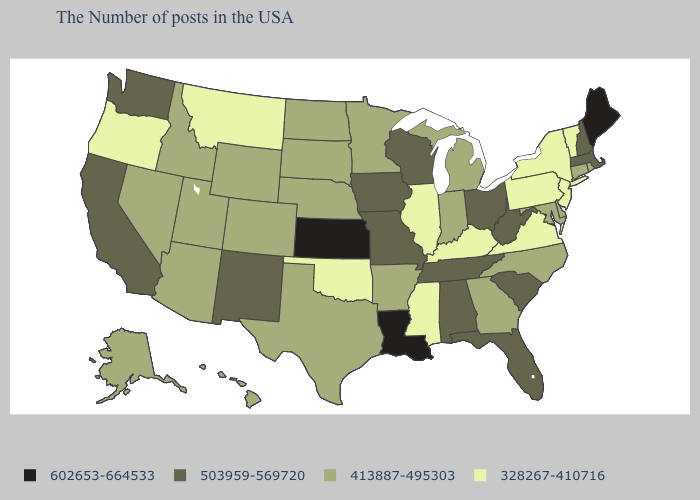Does Indiana have the same value as Kentucky?
Quick response, please. No. What is the lowest value in the USA?
Quick response, please. 328267-410716. How many symbols are there in the legend?
Quick response, please. 4. What is the value of Utah?
Quick response, please. 413887-495303. What is the value of Georgia?
Quick response, please. 413887-495303. Name the states that have a value in the range 413887-495303?
Keep it brief. Rhode Island, Connecticut, Delaware, Maryland, North Carolina, Georgia, Michigan, Indiana, Arkansas, Minnesota, Nebraska, Texas, South Dakota, North Dakota, Wyoming, Colorado, Utah, Arizona, Idaho, Nevada, Alaska, Hawaii. What is the value of Louisiana?
Concise answer only. 602653-664533. Does Rhode Island have a higher value than Maine?
Answer briefly. No. Does the map have missing data?
Answer briefly. No. Name the states that have a value in the range 503959-569720?
Short answer required. Massachusetts, New Hampshire, South Carolina, West Virginia, Ohio, Florida, Alabama, Tennessee, Wisconsin, Missouri, Iowa, New Mexico, California, Washington. What is the lowest value in the MidWest?
Concise answer only. 328267-410716. What is the value of Iowa?
Short answer required. 503959-569720. Does Nevada have a higher value than Georgia?
Answer briefly. No. Does Washington have the highest value in the West?
Give a very brief answer. Yes. 